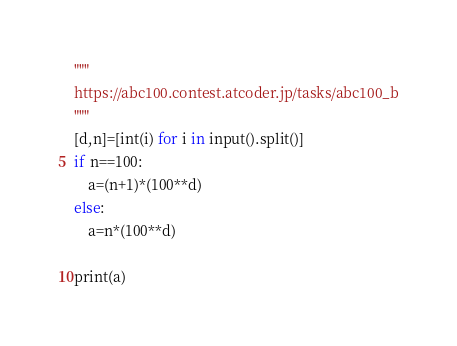<code> <loc_0><loc_0><loc_500><loc_500><_Python_>"""
https://abc100.contest.atcoder.jp/tasks/abc100_b
"""
[d,n]=[int(i) for i in input().split()]
if n==100:
    a=(n+1)*(100**d)
else:
    a=n*(100**d)

print(a)
</code> 